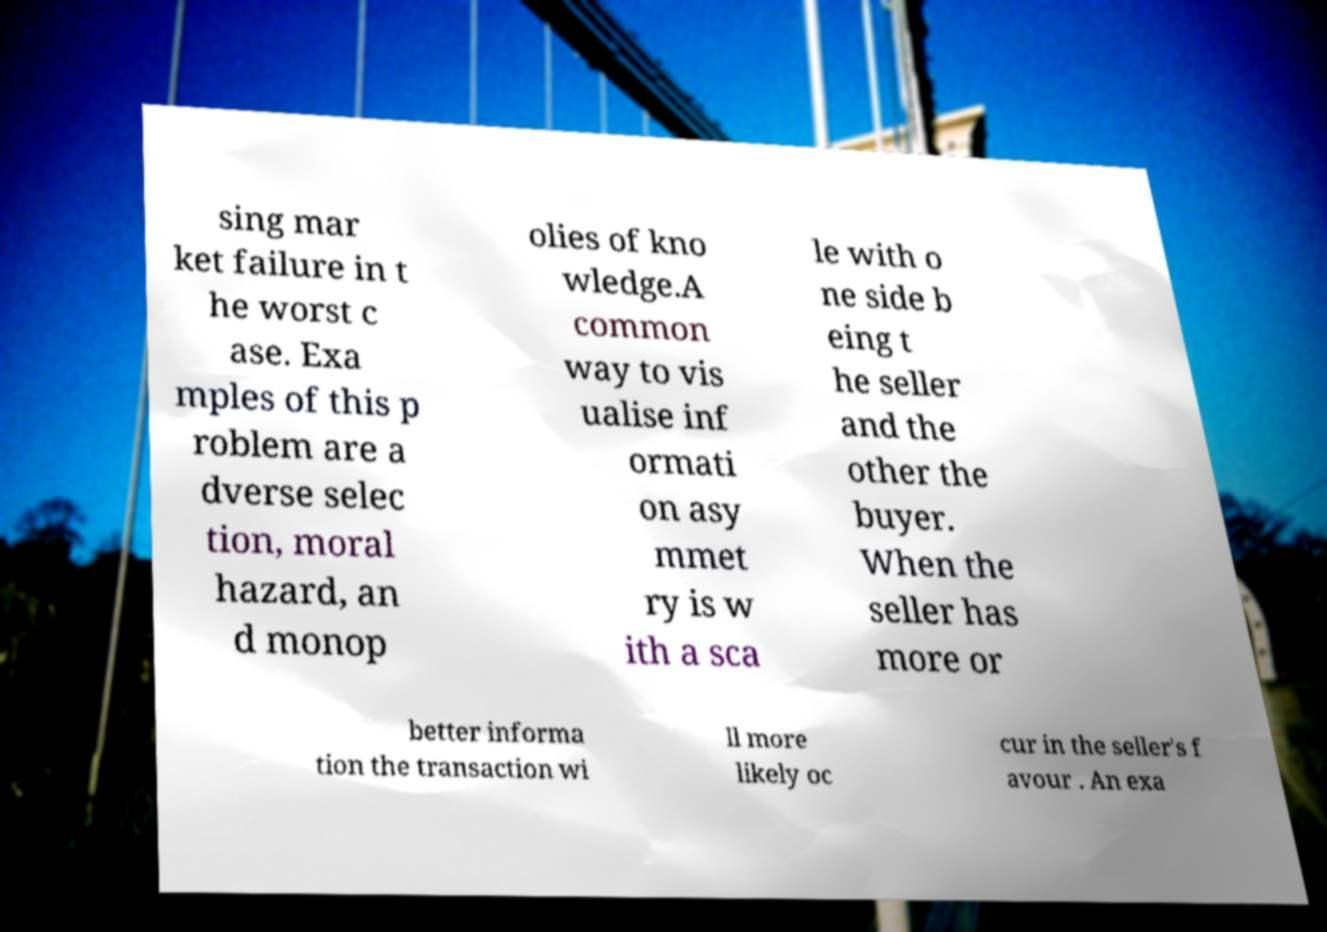There's text embedded in this image that I need extracted. Can you transcribe it verbatim? sing mar ket failure in t he worst c ase. Exa mples of this p roblem are a dverse selec tion, moral hazard, an d monop olies of kno wledge.A common way to vis ualise inf ormati on asy mmet ry is w ith a sca le with o ne side b eing t he seller and the other the buyer. When the seller has more or better informa tion the transaction wi ll more likely oc cur in the seller's f avour . An exa 